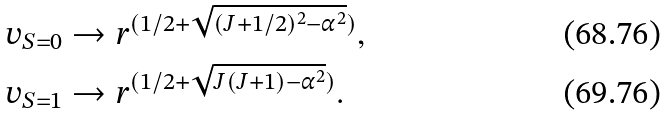Convert formula to latex. <formula><loc_0><loc_0><loc_500><loc_500>v _ { S = 0 } & \rightarrow r ^ { ( 1 / 2 + \sqrt { ( J + 1 / 2 ) ^ { 2 } - \alpha ^ { 2 } } ) } , \\ v _ { S = 1 } & \rightarrow r ^ { ( 1 / 2 + \sqrt { J ( J + 1 ) - \alpha ^ { 2 } } ) } .</formula> 